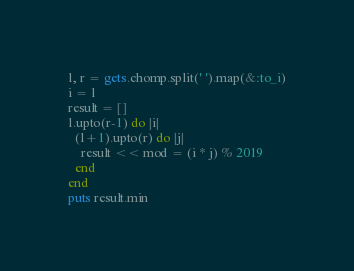Convert code to text. <code><loc_0><loc_0><loc_500><loc_500><_Ruby_>l, r = gets.chomp.split(' ').map(&:to_i)
i = l
result = []
l.upto(r-1) do |i|
  (l+1).upto(r) do |j|
    result << mod = (i * j) % 2019
  end
end  
puts result.min</code> 